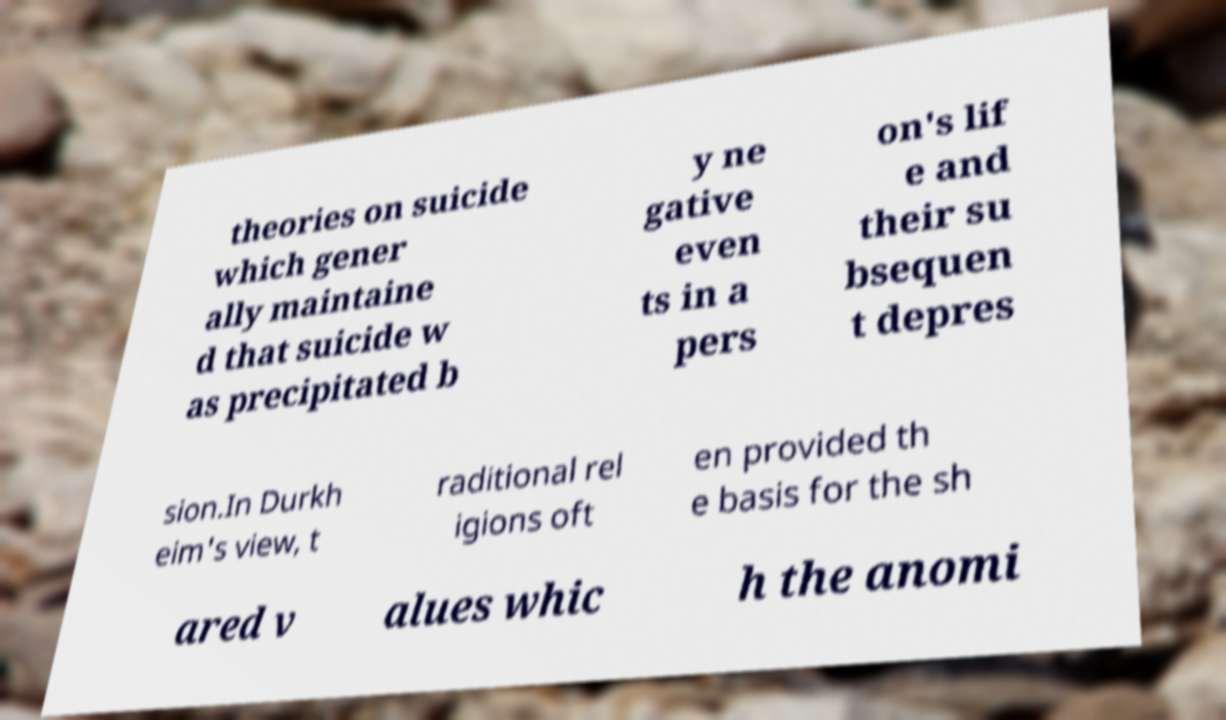For documentation purposes, I need the text within this image transcribed. Could you provide that? theories on suicide which gener ally maintaine d that suicide w as precipitated b y ne gative even ts in a pers on's lif e and their su bsequen t depres sion.In Durkh eim's view, t raditional rel igions oft en provided th e basis for the sh ared v alues whic h the anomi 